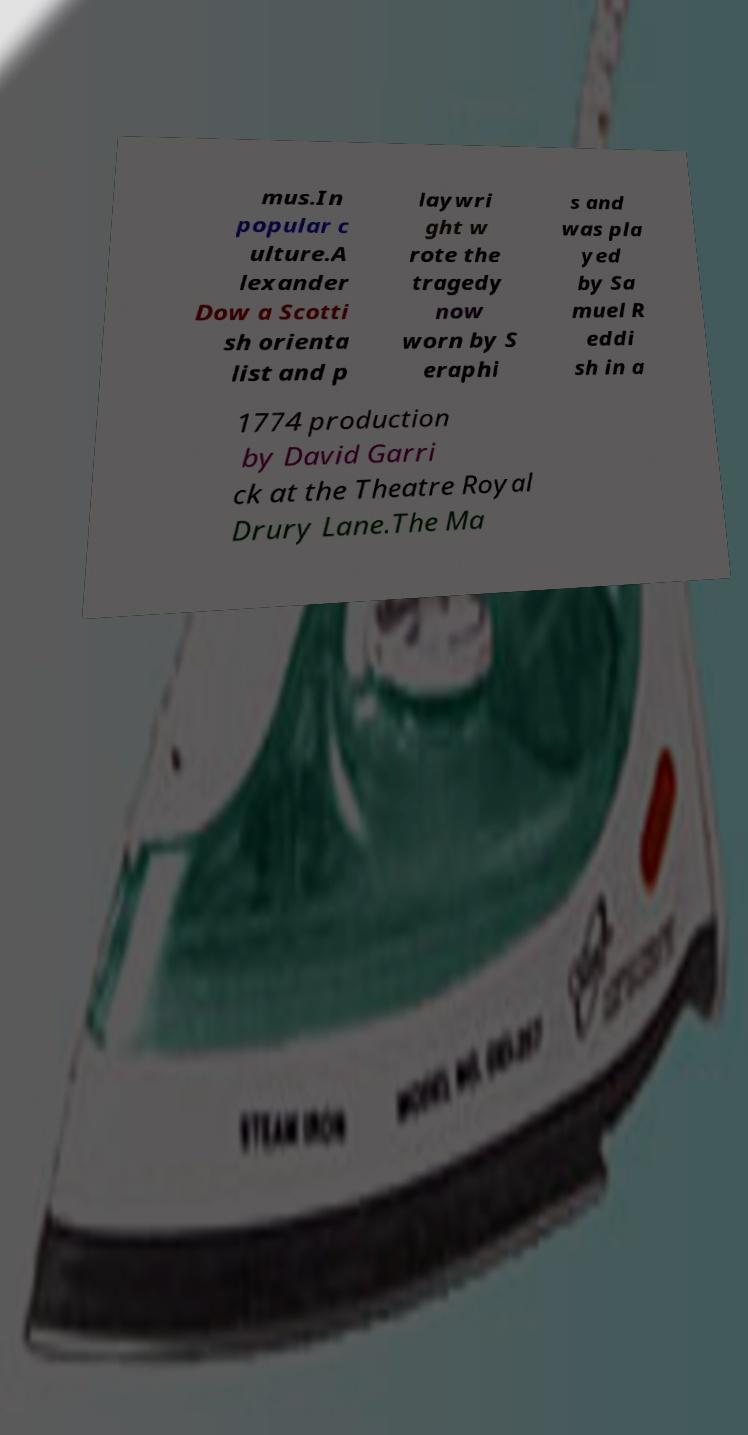Could you extract and type out the text from this image? mus.In popular c ulture.A lexander Dow a Scotti sh orienta list and p laywri ght w rote the tragedy now worn by S eraphi s and was pla yed by Sa muel R eddi sh in a 1774 production by David Garri ck at the Theatre Royal Drury Lane.The Ma 